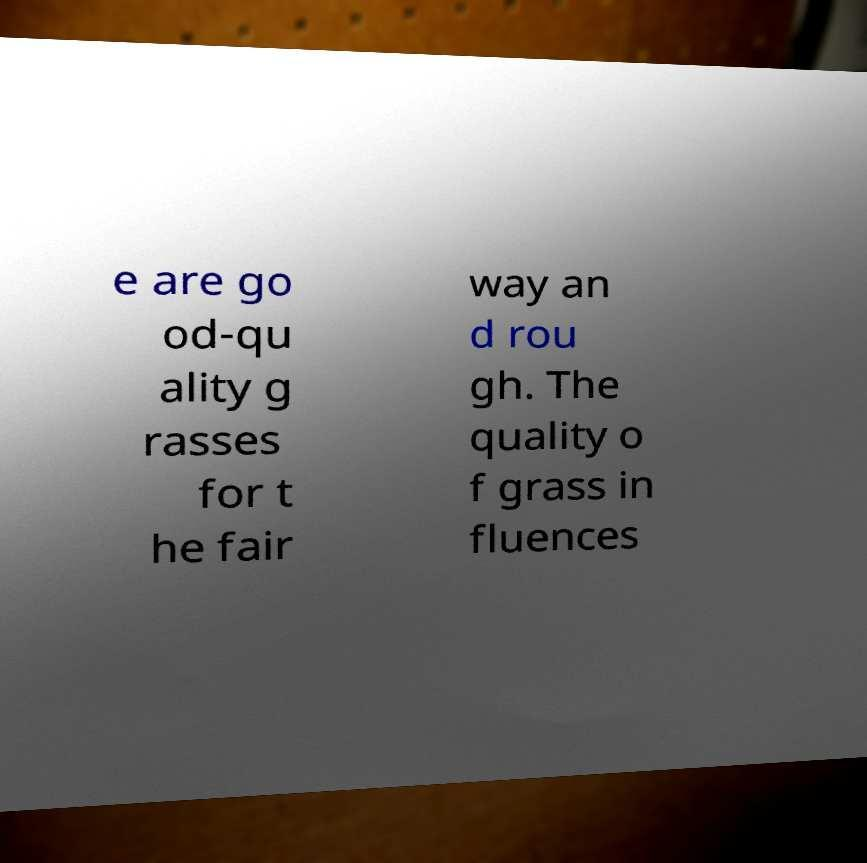I need the written content from this picture converted into text. Can you do that? e are go od-qu ality g rasses for t he fair way an d rou gh. The quality o f grass in fluences 